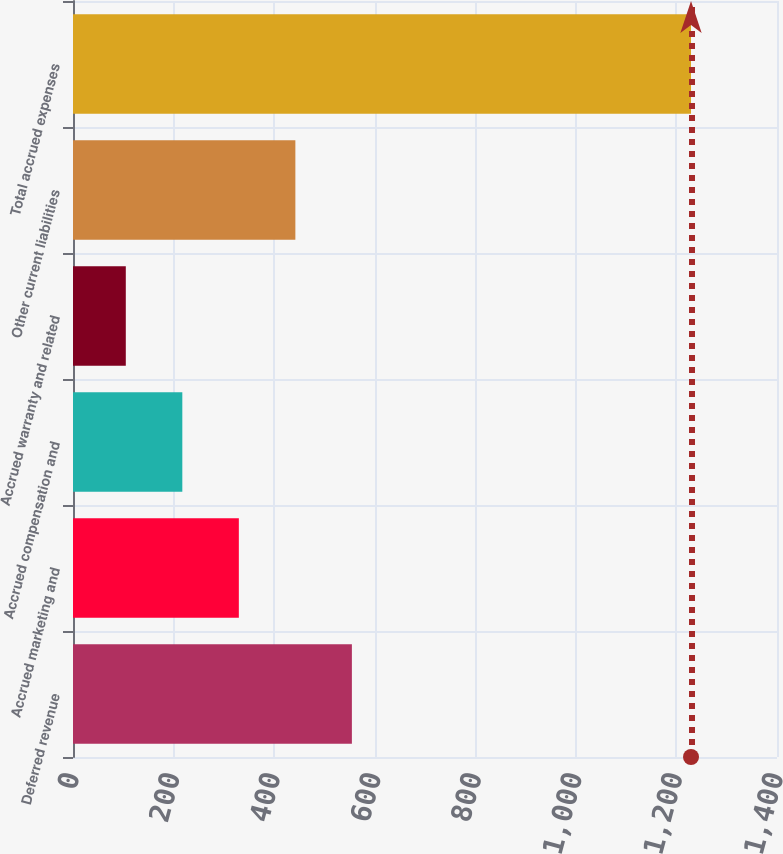Convert chart to OTSL. <chart><loc_0><loc_0><loc_500><loc_500><bar_chart><fcel>Deferred revenue<fcel>Accrued marketing and<fcel>Accrued compensation and<fcel>Accrued warranty and related<fcel>Other current liabilities<fcel>Total accrued expenses<nl><fcel>554.6<fcel>329.8<fcel>217.4<fcel>105<fcel>442.2<fcel>1229<nl></chart> 